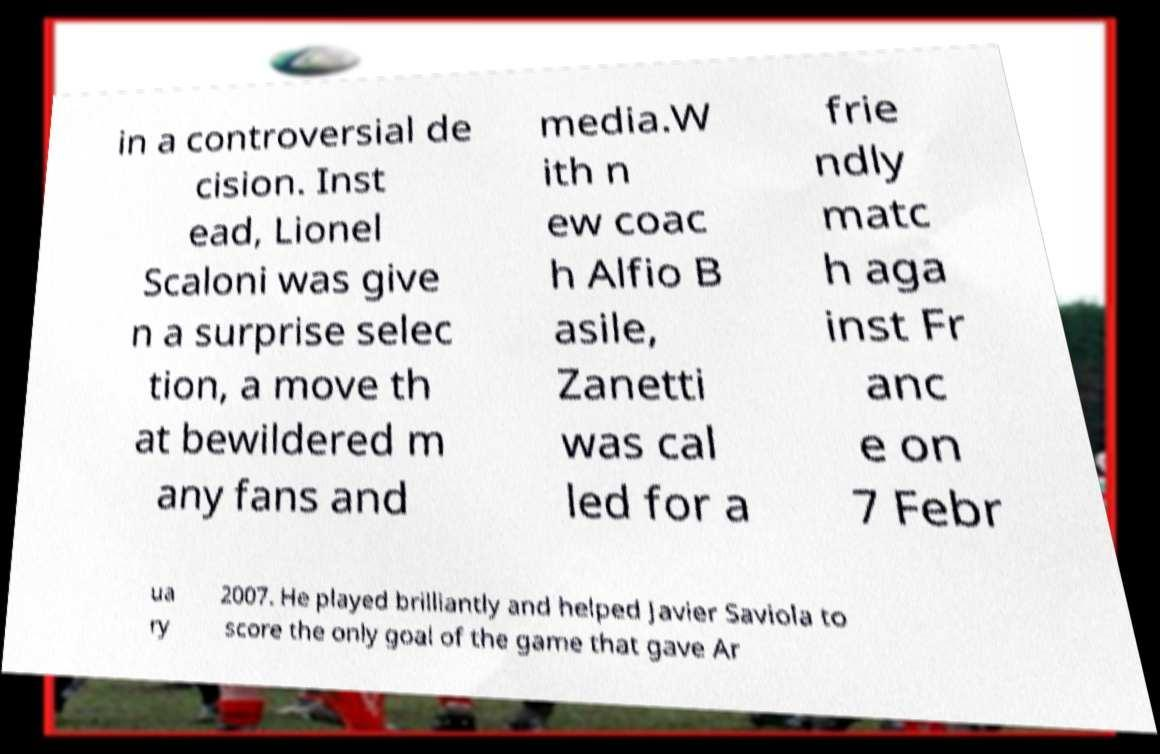I need the written content from this picture converted into text. Can you do that? in a controversial de cision. Inst ead, Lionel Scaloni was give n a surprise selec tion, a move th at bewildered m any fans and media.W ith n ew coac h Alfio B asile, Zanetti was cal led for a frie ndly matc h aga inst Fr anc e on 7 Febr ua ry 2007. He played brilliantly and helped Javier Saviola to score the only goal of the game that gave Ar 